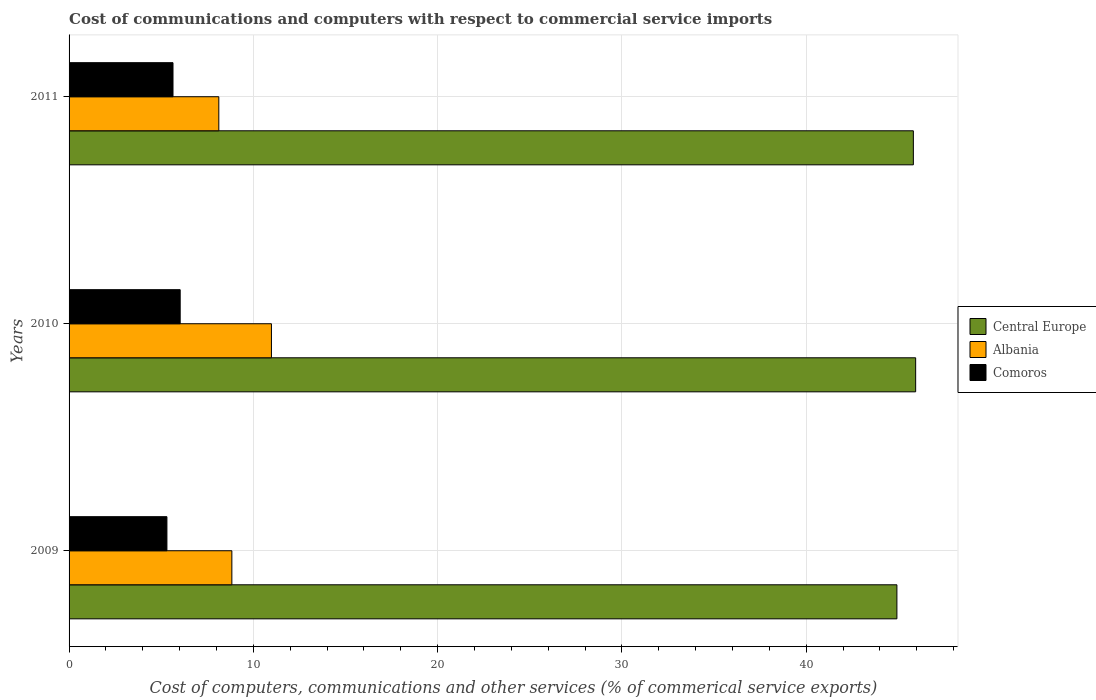How many different coloured bars are there?
Provide a succinct answer. 3. How many groups of bars are there?
Your response must be concise. 3. Are the number of bars per tick equal to the number of legend labels?
Give a very brief answer. Yes. Are the number of bars on each tick of the Y-axis equal?
Offer a terse response. Yes. How many bars are there on the 3rd tick from the top?
Make the answer very short. 3. How many bars are there on the 2nd tick from the bottom?
Provide a succinct answer. 3. What is the label of the 1st group of bars from the top?
Give a very brief answer. 2011. What is the cost of communications and computers in Central Europe in 2011?
Ensure brevity in your answer.  45.81. Across all years, what is the maximum cost of communications and computers in Comoros?
Offer a very short reply. 6.03. Across all years, what is the minimum cost of communications and computers in Comoros?
Provide a short and direct response. 5.31. In which year was the cost of communications and computers in Albania maximum?
Offer a terse response. 2010. In which year was the cost of communications and computers in Central Europe minimum?
Keep it short and to the point. 2009. What is the total cost of communications and computers in Central Europe in the graph?
Your answer should be compact. 136.67. What is the difference between the cost of communications and computers in Comoros in 2009 and that in 2010?
Provide a succinct answer. -0.72. What is the difference between the cost of communications and computers in Comoros in 2010 and the cost of communications and computers in Central Europe in 2009?
Provide a short and direct response. -38.89. What is the average cost of communications and computers in Comoros per year?
Provide a succinct answer. 5.66. In the year 2010, what is the difference between the cost of communications and computers in Central Europe and cost of communications and computers in Albania?
Make the answer very short. 34.96. What is the ratio of the cost of communications and computers in Albania in 2009 to that in 2010?
Offer a very short reply. 0.8. Is the difference between the cost of communications and computers in Central Europe in 2009 and 2011 greater than the difference between the cost of communications and computers in Albania in 2009 and 2011?
Provide a succinct answer. No. What is the difference between the highest and the second highest cost of communications and computers in Albania?
Provide a short and direct response. 2.15. What is the difference between the highest and the lowest cost of communications and computers in Central Europe?
Your answer should be compact. 1.02. In how many years, is the cost of communications and computers in Albania greater than the average cost of communications and computers in Albania taken over all years?
Provide a short and direct response. 1. Is the sum of the cost of communications and computers in Albania in 2010 and 2011 greater than the maximum cost of communications and computers in Central Europe across all years?
Provide a short and direct response. No. What does the 3rd bar from the top in 2010 represents?
Keep it short and to the point. Central Europe. What does the 3rd bar from the bottom in 2011 represents?
Your answer should be very brief. Comoros. Is it the case that in every year, the sum of the cost of communications and computers in Albania and cost of communications and computers in Central Europe is greater than the cost of communications and computers in Comoros?
Your response must be concise. Yes. How many bars are there?
Provide a succinct answer. 9. Are all the bars in the graph horizontal?
Offer a terse response. Yes. Does the graph contain grids?
Your answer should be compact. Yes. How many legend labels are there?
Your answer should be very brief. 3. What is the title of the graph?
Make the answer very short. Cost of communications and computers with respect to commercial service imports. What is the label or title of the X-axis?
Your answer should be compact. Cost of computers, communications and other services (% of commerical service exports). What is the label or title of the Y-axis?
Offer a very short reply. Years. What is the Cost of computers, communications and other services (% of commerical service exports) of Central Europe in 2009?
Your answer should be compact. 44.92. What is the Cost of computers, communications and other services (% of commerical service exports) in Albania in 2009?
Give a very brief answer. 8.83. What is the Cost of computers, communications and other services (% of commerical service exports) in Comoros in 2009?
Your response must be concise. 5.31. What is the Cost of computers, communications and other services (% of commerical service exports) of Central Europe in 2010?
Provide a short and direct response. 45.94. What is the Cost of computers, communications and other services (% of commerical service exports) in Albania in 2010?
Your answer should be very brief. 10.98. What is the Cost of computers, communications and other services (% of commerical service exports) of Comoros in 2010?
Keep it short and to the point. 6.03. What is the Cost of computers, communications and other services (% of commerical service exports) in Central Europe in 2011?
Make the answer very short. 45.81. What is the Cost of computers, communications and other services (% of commerical service exports) in Albania in 2011?
Offer a terse response. 8.13. What is the Cost of computers, communications and other services (% of commerical service exports) of Comoros in 2011?
Offer a very short reply. 5.64. Across all years, what is the maximum Cost of computers, communications and other services (% of commerical service exports) of Central Europe?
Keep it short and to the point. 45.94. Across all years, what is the maximum Cost of computers, communications and other services (% of commerical service exports) of Albania?
Ensure brevity in your answer.  10.98. Across all years, what is the maximum Cost of computers, communications and other services (% of commerical service exports) in Comoros?
Offer a very short reply. 6.03. Across all years, what is the minimum Cost of computers, communications and other services (% of commerical service exports) in Central Europe?
Provide a succinct answer. 44.92. Across all years, what is the minimum Cost of computers, communications and other services (% of commerical service exports) of Albania?
Your answer should be very brief. 8.13. Across all years, what is the minimum Cost of computers, communications and other services (% of commerical service exports) of Comoros?
Your answer should be compact. 5.31. What is the total Cost of computers, communications and other services (% of commerical service exports) of Central Europe in the graph?
Your answer should be compact. 136.67. What is the total Cost of computers, communications and other services (% of commerical service exports) of Albania in the graph?
Offer a terse response. 27.94. What is the total Cost of computers, communications and other services (% of commerical service exports) of Comoros in the graph?
Offer a very short reply. 16.98. What is the difference between the Cost of computers, communications and other services (% of commerical service exports) in Central Europe in 2009 and that in 2010?
Your answer should be very brief. -1.02. What is the difference between the Cost of computers, communications and other services (% of commerical service exports) in Albania in 2009 and that in 2010?
Give a very brief answer. -2.15. What is the difference between the Cost of computers, communications and other services (% of commerical service exports) in Comoros in 2009 and that in 2010?
Give a very brief answer. -0.72. What is the difference between the Cost of computers, communications and other services (% of commerical service exports) of Central Europe in 2009 and that in 2011?
Provide a succinct answer. -0.89. What is the difference between the Cost of computers, communications and other services (% of commerical service exports) of Albania in 2009 and that in 2011?
Ensure brevity in your answer.  0.71. What is the difference between the Cost of computers, communications and other services (% of commerical service exports) of Comoros in 2009 and that in 2011?
Provide a short and direct response. -0.33. What is the difference between the Cost of computers, communications and other services (% of commerical service exports) in Central Europe in 2010 and that in 2011?
Offer a very short reply. 0.13. What is the difference between the Cost of computers, communications and other services (% of commerical service exports) of Albania in 2010 and that in 2011?
Your response must be concise. 2.86. What is the difference between the Cost of computers, communications and other services (% of commerical service exports) in Comoros in 2010 and that in 2011?
Keep it short and to the point. 0.39. What is the difference between the Cost of computers, communications and other services (% of commerical service exports) in Central Europe in 2009 and the Cost of computers, communications and other services (% of commerical service exports) in Albania in 2010?
Your answer should be very brief. 33.94. What is the difference between the Cost of computers, communications and other services (% of commerical service exports) of Central Europe in 2009 and the Cost of computers, communications and other services (% of commerical service exports) of Comoros in 2010?
Keep it short and to the point. 38.89. What is the difference between the Cost of computers, communications and other services (% of commerical service exports) of Albania in 2009 and the Cost of computers, communications and other services (% of commerical service exports) of Comoros in 2010?
Your answer should be very brief. 2.8. What is the difference between the Cost of computers, communications and other services (% of commerical service exports) of Central Europe in 2009 and the Cost of computers, communications and other services (% of commerical service exports) of Albania in 2011?
Your answer should be compact. 36.8. What is the difference between the Cost of computers, communications and other services (% of commerical service exports) in Central Europe in 2009 and the Cost of computers, communications and other services (% of commerical service exports) in Comoros in 2011?
Provide a succinct answer. 39.28. What is the difference between the Cost of computers, communications and other services (% of commerical service exports) of Albania in 2009 and the Cost of computers, communications and other services (% of commerical service exports) of Comoros in 2011?
Give a very brief answer. 3.19. What is the difference between the Cost of computers, communications and other services (% of commerical service exports) of Central Europe in 2010 and the Cost of computers, communications and other services (% of commerical service exports) of Albania in 2011?
Keep it short and to the point. 37.81. What is the difference between the Cost of computers, communications and other services (% of commerical service exports) of Central Europe in 2010 and the Cost of computers, communications and other services (% of commerical service exports) of Comoros in 2011?
Your answer should be compact. 40.3. What is the difference between the Cost of computers, communications and other services (% of commerical service exports) of Albania in 2010 and the Cost of computers, communications and other services (% of commerical service exports) of Comoros in 2011?
Provide a short and direct response. 5.34. What is the average Cost of computers, communications and other services (% of commerical service exports) in Central Europe per year?
Provide a succinct answer. 45.56. What is the average Cost of computers, communications and other services (% of commerical service exports) in Albania per year?
Provide a succinct answer. 9.31. What is the average Cost of computers, communications and other services (% of commerical service exports) of Comoros per year?
Make the answer very short. 5.66. In the year 2009, what is the difference between the Cost of computers, communications and other services (% of commerical service exports) of Central Europe and Cost of computers, communications and other services (% of commerical service exports) of Albania?
Give a very brief answer. 36.09. In the year 2009, what is the difference between the Cost of computers, communications and other services (% of commerical service exports) in Central Europe and Cost of computers, communications and other services (% of commerical service exports) in Comoros?
Give a very brief answer. 39.61. In the year 2009, what is the difference between the Cost of computers, communications and other services (% of commerical service exports) of Albania and Cost of computers, communications and other services (% of commerical service exports) of Comoros?
Provide a short and direct response. 3.52. In the year 2010, what is the difference between the Cost of computers, communications and other services (% of commerical service exports) of Central Europe and Cost of computers, communications and other services (% of commerical service exports) of Albania?
Your answer should be very brief. 34.96. In the year 2010, what is the difference between the Cost of computers, communications and other services (% of commerical service exports) in Central Europe and Cost of computers, communications and other services (% of commerical service exports) in Comoros?
Offer a very short reply. 39.91. In the year 2010, what is the difference between the Cost of computers, communications and other services (% of commerical service exports) in Albania and Cost of computers, communications and other services (% of commerical service exports) in Comoros?
Provide a short and direct response. 4.95. In the year 2011, what is the difference between the Cost of computers, communications and other services (% of commerical service exports) in Central Europe and Cost of computers, communications and other services (% of commerical service exports) in Albania?
Provide a short and direct response. 37.69. In the year 2011, what is the difference between the Cost of computers, communications and other services (% of commerical service exports) in Central Europe and Cost of computers, communications and other services (% of commerical service exports) in Comoros?
Your response must be concise. 40.17. In the year 2011, what is the difference between the Cost of computers, communications and other services (% of commerical service exports) in Albania and Cost of computers, communications and other services (% of commerical service exports) in Comoros?
Provide a short and direct response. 2.49. What is the ratio of the Cost of computers, communications and other services (% of commerical service exports) of Central Europe in 2009 to that in 2010?
Give a very brief answer. 0.98. What is the ratio of the Cost of computers, communications and other services (% of commerical service exports) in Albania in 2009 to that in 2010?
Ensure brevity in your answer.  0.8. What is the ratio of the Cost of computers, communications and other services (% of commerical service exports) of Comoros in 2009 to that in 2010?
Give a very brief answer. 0.88. What is the ratio of the Cost of computers, communications and other services (% of commerical service exports) in Central Europe in 2009 to that in 2011?
Provide a short and direct response. 0.98. What is the ratio of the Cost of computers, communications and other services (% of commerical service exports) of Albania in 2009 to that in 2011?
Provide a succinct answer. 1.09. What is the ratio of the Cost of computers, communications and other services (% of commerical service exports) in Comoros in 2009 to that in 2011?
Give a very brief answer. 0.94. What is the ratio of the Cost of computers, communications and other services (% of commerical service exports) in Central Europe in 2010 to that in 2011?
Your answer should be compact. 1. What is the ratio of the Cost of computers, communications and other services (% of commerical service exports) in Albania in 2010 to that in 2011?
Offer a terse response. 1.35. What is the ratio of the Cost of computers, communications and other services (% of commerical service exports) of Comoros in 2010 to that in 2011?
Provide a short and direct response. 1.07. What is the difference between the highest and the second highest Cost of computers, communications and other services (% of commerical service exports) of Central Europe?
Your answer should be compact. 0.13. What is the difference between the highest and the second highest Cost of computers, communications and other services (% of commerical service exports) in Albania?
Offer a very short reply. 2.15. What is the difference between the highest and the second highest Cost of computers, communications and other services (% of commerical service exports) in Comoros?
Provide a short and direct response. 0.39. What is the difference between the highest and the lowest Cost of computers, communications and other services (% of commerical service exports) in Central Europe?
Offer a very short reply. 1.02. What is the difference between the highest and the lowest Cost of computers, communications and other services (% of commerical service exports) of Albania?
Offer a very short reply. 2.86. What is the difference between the highest and the lowest Cost of computers, communications and other services (% of commerical service exports) in Comoros?
Provide a succinct answer. 0.72. 